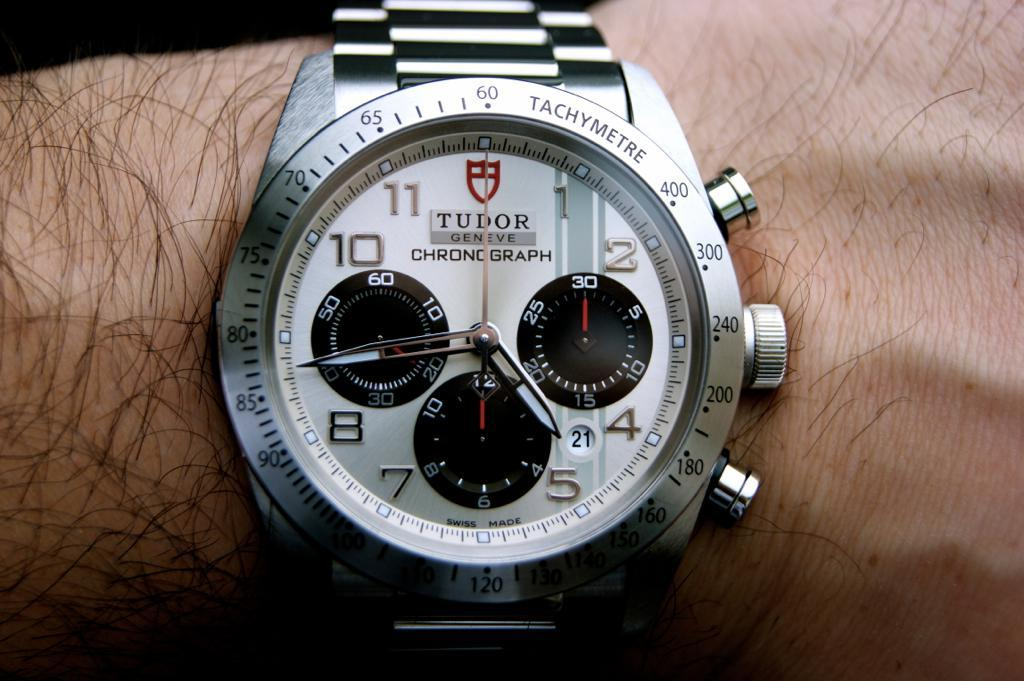<image>
Share a concise interpretation of the image provided. the Tudor watch is on the mans wrist 